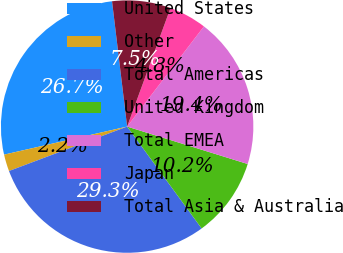Convert chart. <chart><loc_0><loc_0><loc_500><loc_500><pie_chart><fcel>United States<fcel>Other<fcel>Total Americas<fcel>United Kingdom<fcel>Total EMEA<fcel>Japan<fcel>Total Asia & Australia<nl><fcel>26.66%<fcel>2.16%<fcel>29.32%<fcel>10.16%<fcel>19.38%<fcel>4.83%<fcel>7.49%<nl></chart> 